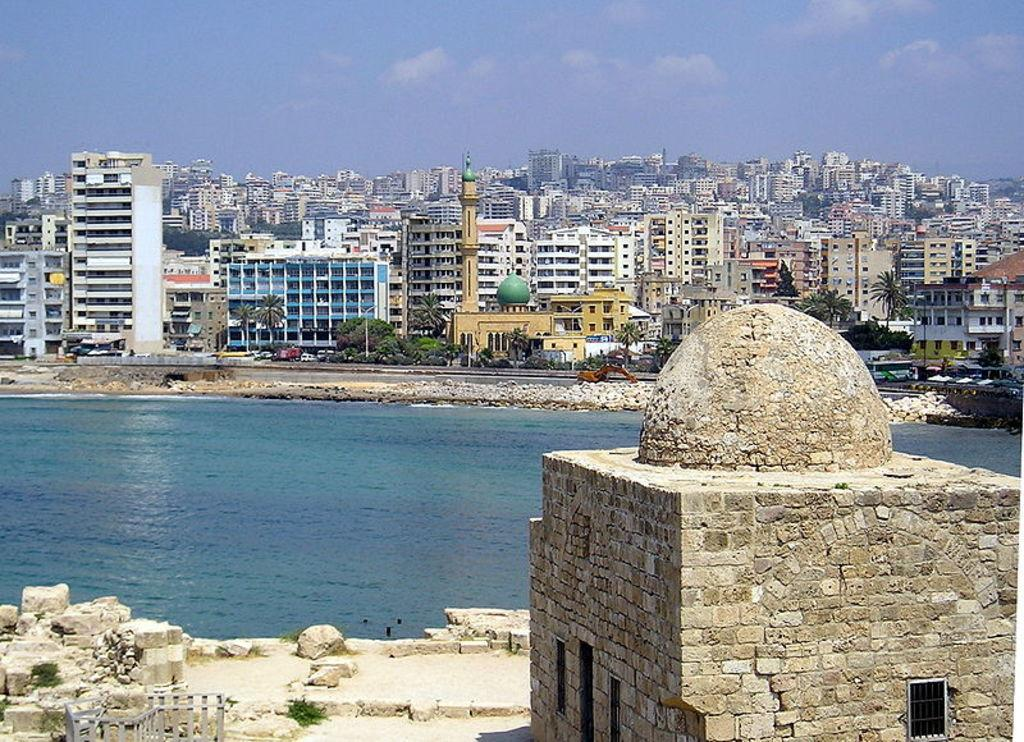What is the main feature in the center of the image? There is water in the center of the image. What can be seen on the ground in the front of the image? There are stones on the ground in the front of the image. What type of structure is present in the image? There is a house in the image. What can be seen in the background of the image? There are buildings in the background of the image. How would you describe the sky in the image? The sky is cloudy in the image. Where is the dirt located in the image? There is no dirt present in the image. What type of bulb is illuminating the water in the image? There is no bulb present in the image, and the water is not illuminated. 